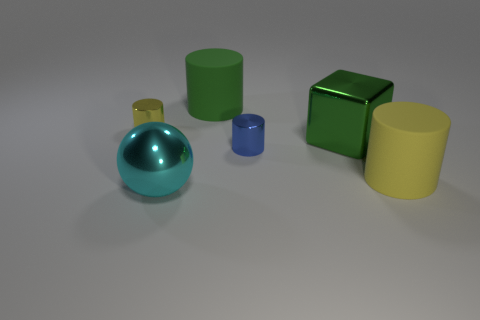How many other big green rubber things are the same shape as the large green matte object?
Your response must be concise. 0. There is another cylinder that is the same material as the blue cylinder; what is its size?
Ensure brevity in your answer.  Small. What number of cylinders are the same size as the yellow rubber object?
Offer a very short reply. 1. What is the size of the cylinder that is the same color as the big block?
Provide a short and direct response. Large. What is the color of the large matte thing behind the rubber thing that is to the right of the big green cylinder?
Offer a terse response. Green. Are there any big objects that have the same color as the shiny sphere?
Your response must be concise. No. The other metallic cylinder that is the same size as the blue cylinder is what color?
Your response must be concise. Yellow. Does the object to the left of the big cyan metal sphere have the same material as the large cube?
Keep it short and to the point. Yes. There is a tiny object that is left of the small metallic cylinder in front of the tiny yellow metal cylinder; are there any tiny blue metal cylinders that are to the left of it?
Provide a short and direct response. No. There is a tiny blue shiny object behind the large ball; is its shape the same as the large green matte thing?
Keep it short and to the point. Yes. 